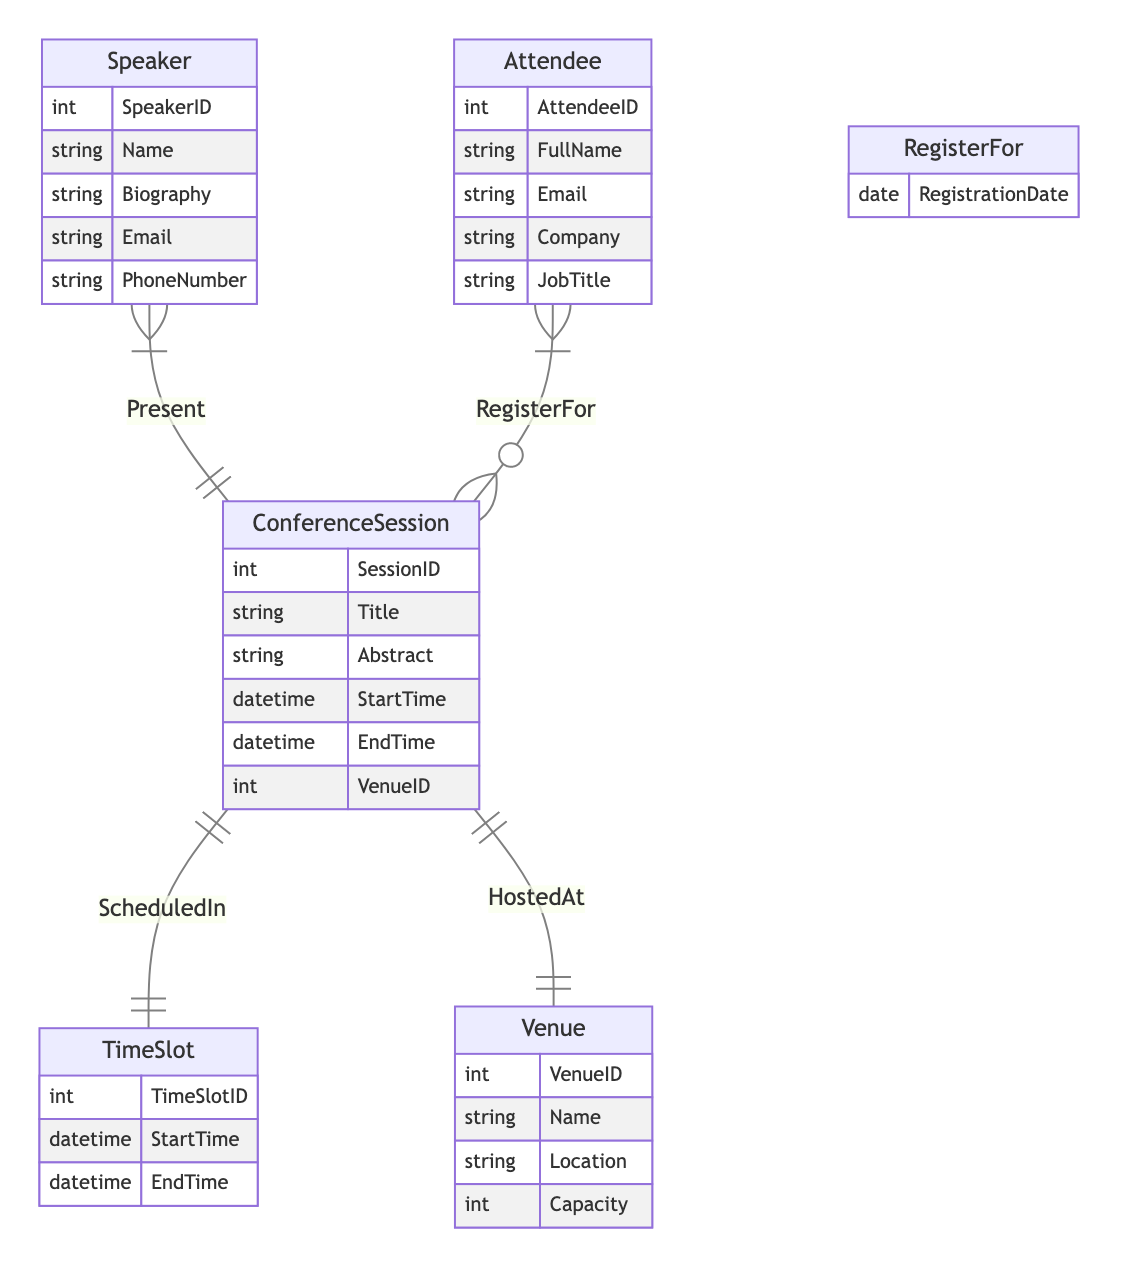What is the primary key for the ConferenceSession entity? The primary key is represented by the attribute "SessionID". This ID uniquely identifies each ConferenceSession in the diagram.
Answer: SessionID How many entities are there in the diagram? Counting the entities listed, we find five: ConferenceSession, Speaker, Attendee, TimeSlot, and Venue.
Answer: 5 What relationship connects ConferenceSession and TimeSlot? The relationship between ConferenceSession and TimeSlot is named "ScheduledIn", indicating that sessions are assigned to specific time slots.
Answer: ScheduledIn Which entity contains the attribute "Biography"? The attribute "Biography" is found in the Speaker entity, which provides details about each speaker's background.
Answer: Speaker What is the relationship between a Speaker and a ConferenceSession? The relationship is called "Present". This indicates that speakers present specific sessions during the conference.
Answer: Present What attribute in the RegisterFor relationship signifies the date of attendee registration? The attribute "RegistrationDate" specifically indicates when an attendee registered for a session in the RegisterFor relationship.
Answer: RegistrationDate How many attributes does the Venue entity have? The Venue entity includes four attributes: VenueID, Name, Location, and Capacity. Counting these gives a total of four attributes.
Answer: 4 Which entity is related to the ConferenceSession through the HostedAt relationship? The Venue entity is related to ConferenceSession via the HostedAt relationship, signifying where the session is hosted.
Answer: Venue 